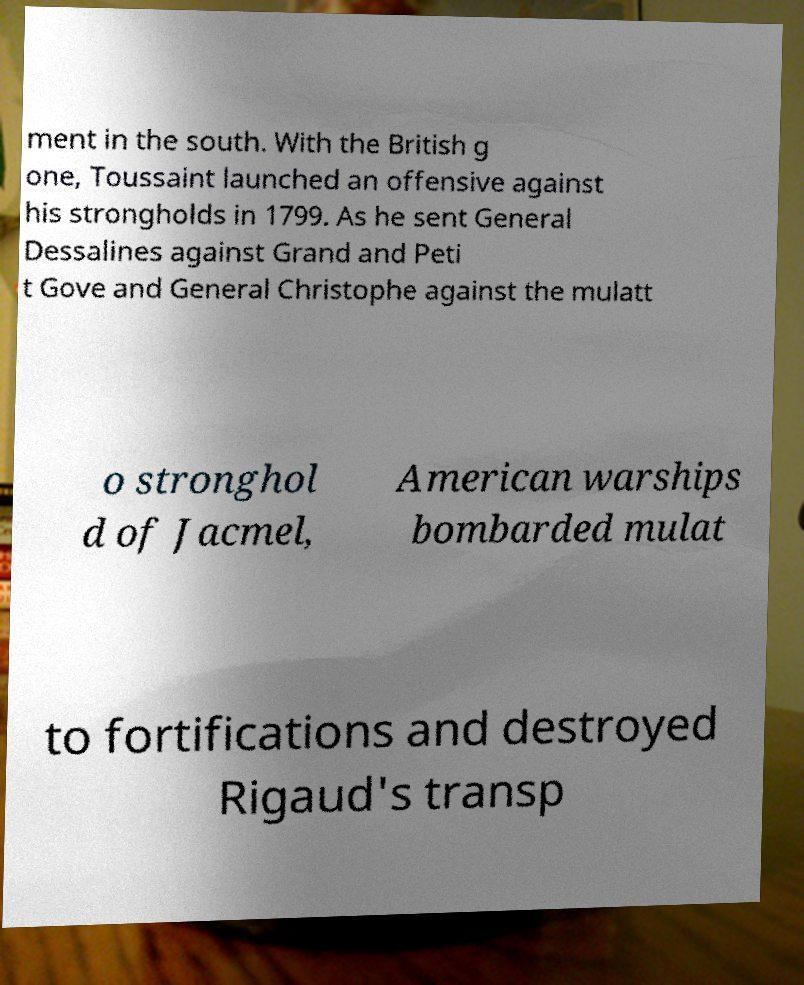There's text embedded in this image that I need extracted. Can you transcribe it verbatim? ment in the south. With the British g one, Toussaint launched an offensive against his strongholds in 1799. As he sent General Dessalines against Grand and Peti t Gove and General Christophe against the mulatt o stronghol d of Jacmel, American warships bombarded mulat to fortifications and destroyed Rigaud's transp 